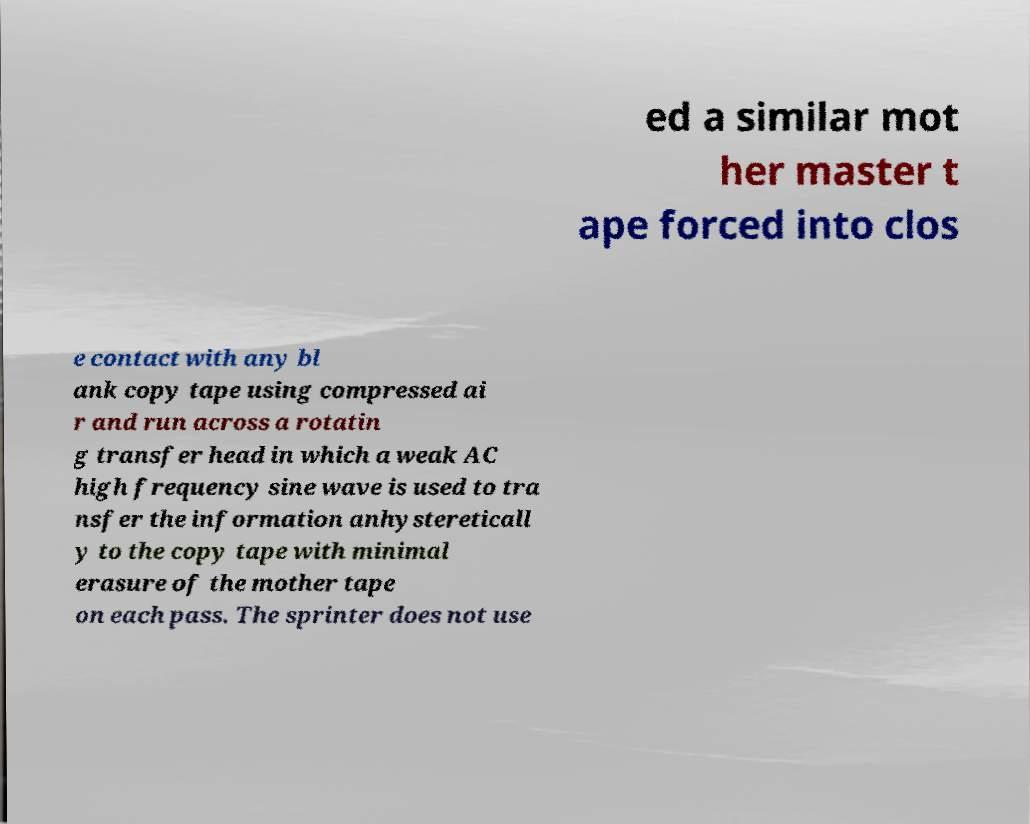Can you read and provide the text displayed in the image?This photo seems to have some interesting text. Can you extract and type it out for me? ed a similar mot her master t ape forced into clos e contact with any bl ank copy tape using compressed ai r and run across a rotatin g transfer head in which a weak AC high frequency sine wave is used to tra nsfer the information anhystereticall y to the copy tape with minimal erasure of the mother tape on each pass. The sprinter does not use 